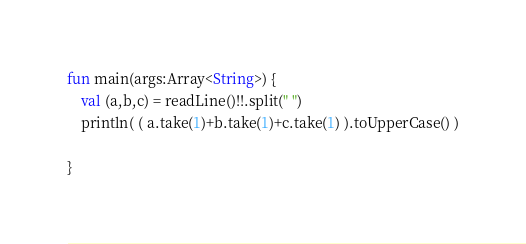<code> <loc_0><loc_0><loc_500><loc_500><_Kotlin_>fun main(args:Array<String>) {
	val (a,b,c) = readLine()!!.split(" ")
	println( ( a.take(1)+b.take(1)+c.take(1) ).toUpperCase() )
	
}</code> 